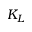Convert formula to latex. <formula><loc_0><loc_0><loc_500><loc_500>K _ { L }</formula> 